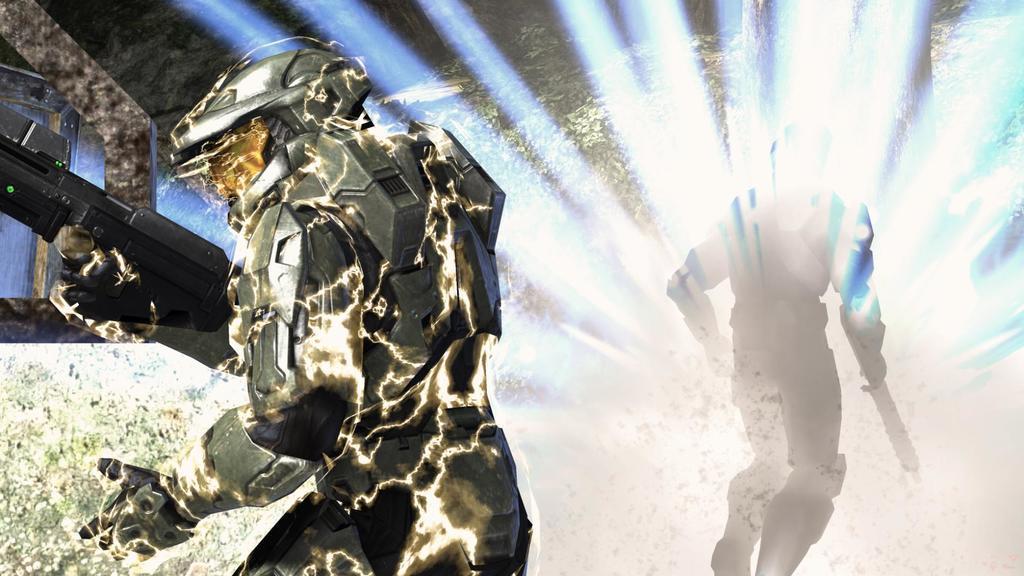Could you give a brief overview of what you see in this image? This is an animation and on the right, we can see a person's shadow holding an object and on the left, there is a person holding gun and in the background, there is a wall. 